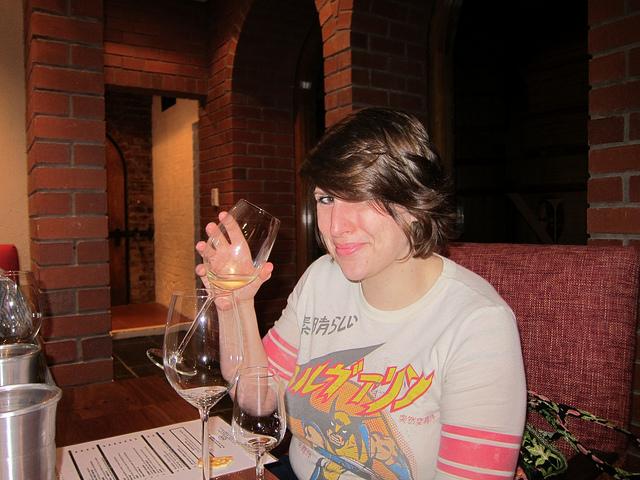Which hand is this woman using to hold the wine glass?
Give a very brief answer. Right. What is the girl celebrating?
Short answer required. Birthday. Is this a bakery?
Quick response, please. No. What is the girl holding?
Give a very brief answer. Glass. Is the woman laughing?
Quick response, please. No. Is this woman probably an X-Men fan?
Keep it brief. Yes. What are the walls made of in this room?
Answer briefly. Brick. 